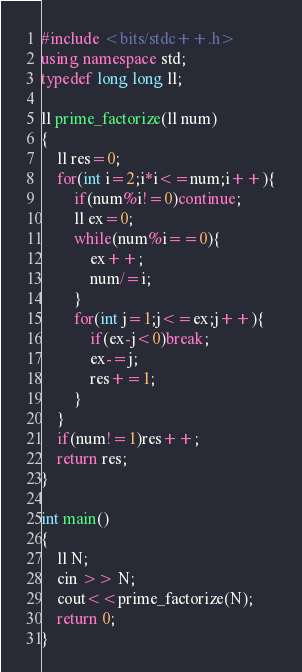Convert code to text. <code><loc_0><loc_0><loc_500><loc_500><_C++_>#include <bits/stdc++.h>
using namespace std;
typedef long long ll;

ll prime_factorize(ll num)
{
    ll res=0;
    for(int i=2;i*i<=num;i++){
        if(num%i!=0)continue;
        ll ex=0;
        while(num%i==0){
            ex++;
            num/=i;
        }
        for(int j=1;j<=ex;j++){
            if(ex-j<0)break;
            ex-=j;
            res+=1;
        }
    }
    if(num!=1)res++;
    return res;
}

int main()
{
    ll N;
    cin >> N;
    cout<<prime_factorize(N);
    return 0;
}
</code> 